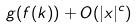Convert formula to latex. <formula><loc_0><loc_0><loc_500><loc_500>g ( f ( k ) ) + O ( | x | ^ { c } )</formula> 